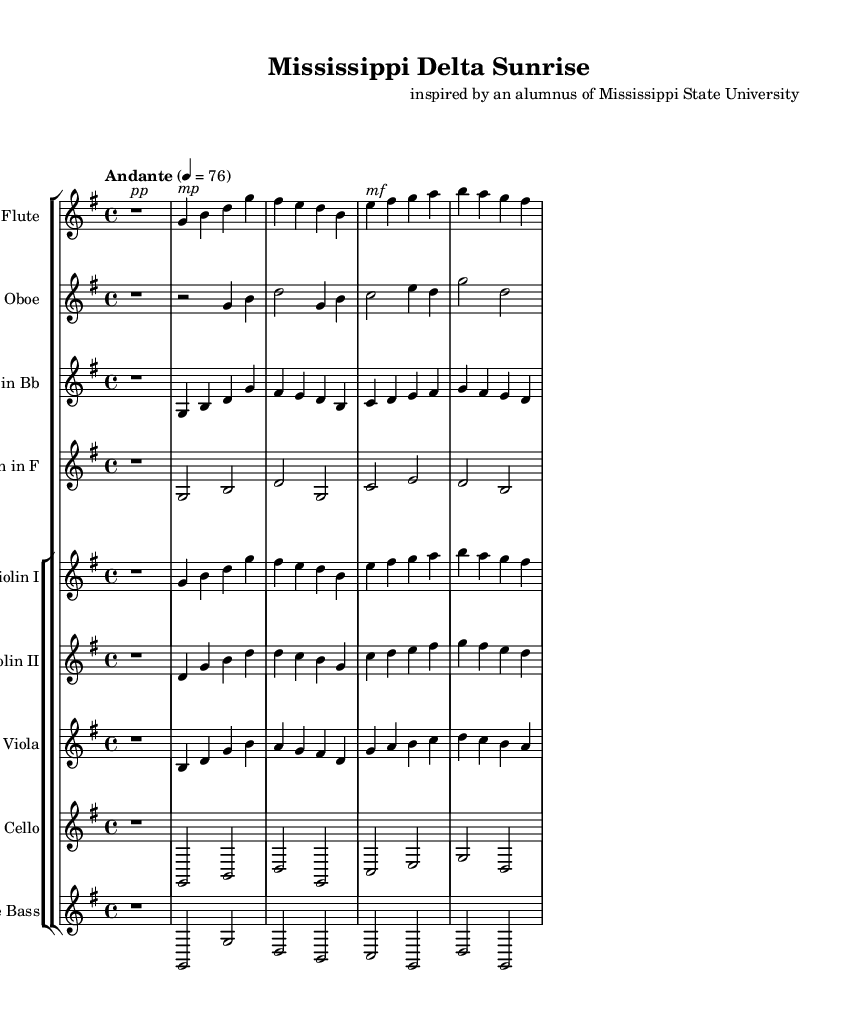What is the key signature of this music? The key signature indicated in the music is G major, which has one sharp (F#). This can be identified by looking at the key signature at the beginning of the staff where the sharps appear.
Answer: G major What is the time signature of this music? The time signature is 4/4, which can be found at the beginning of the score next to the key signature. This means there are four beats in each measure, and the quarter note gets one beat.
Answer: 4/4 What is the tempo marking for this piece? The tempo marking is "Andante," which indicates a moderate walking pace. This is mentioned at the beginning of the score alongside the metronome marking of quarter note equals 76.
Answer: Andante Which instruments are featured in this symphony? The instruments featured include Flute, Oboe, Clarinet in B flat, Horn in F, Violin I, Violin II, Viola, Cello, and Double Bass. These can be found in the title of each staff in the score.
Answer: Flute, Oboe, Clarinet in B flat, Horn in F, Violin I, Violin II, Viola, Cello, Double Bass What is the dynamics indication for the flute at the beginning? The dynamics indication for the flute at the beginning is "pp," which stands for pianissimo, meaning very soft. This is noted above the rest, indicating how the first note should be played.
Answer: pp Which instrument plays the lowest notes in this piece? The Double Bass plays the lowest notes in the orchestration, as it is the lowest-pitched string instrument in the score. Looking at the score, its notes are situated the lowest on the staff.
Answer: Double Bass 